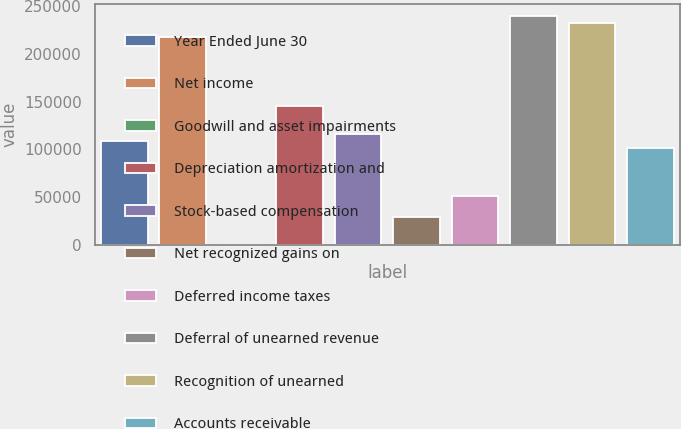<chart> <loc_0><loc_0><loc_500><loc_500><bar_chart><fcel>Year Ended June 30<fcel>Net income<fcel>Goodwill and asset impairments<fcel>Depreciation amortization and<fcel>Stock-based compensation<fcel>Net recognized gains on<fcel>Deferred income taxes<fcel>Deferral of unearned revenue<fcel>Recognition of unearned<fcel>Accounts receivable<nl><fcel>109035<fcel>218069<fcel>0.73<fcel>145379<fcel>116304<fcel>29076.5<fcel>50883.2<fcel>239875<fcel>232606<fcel>101766<nl></chart> 